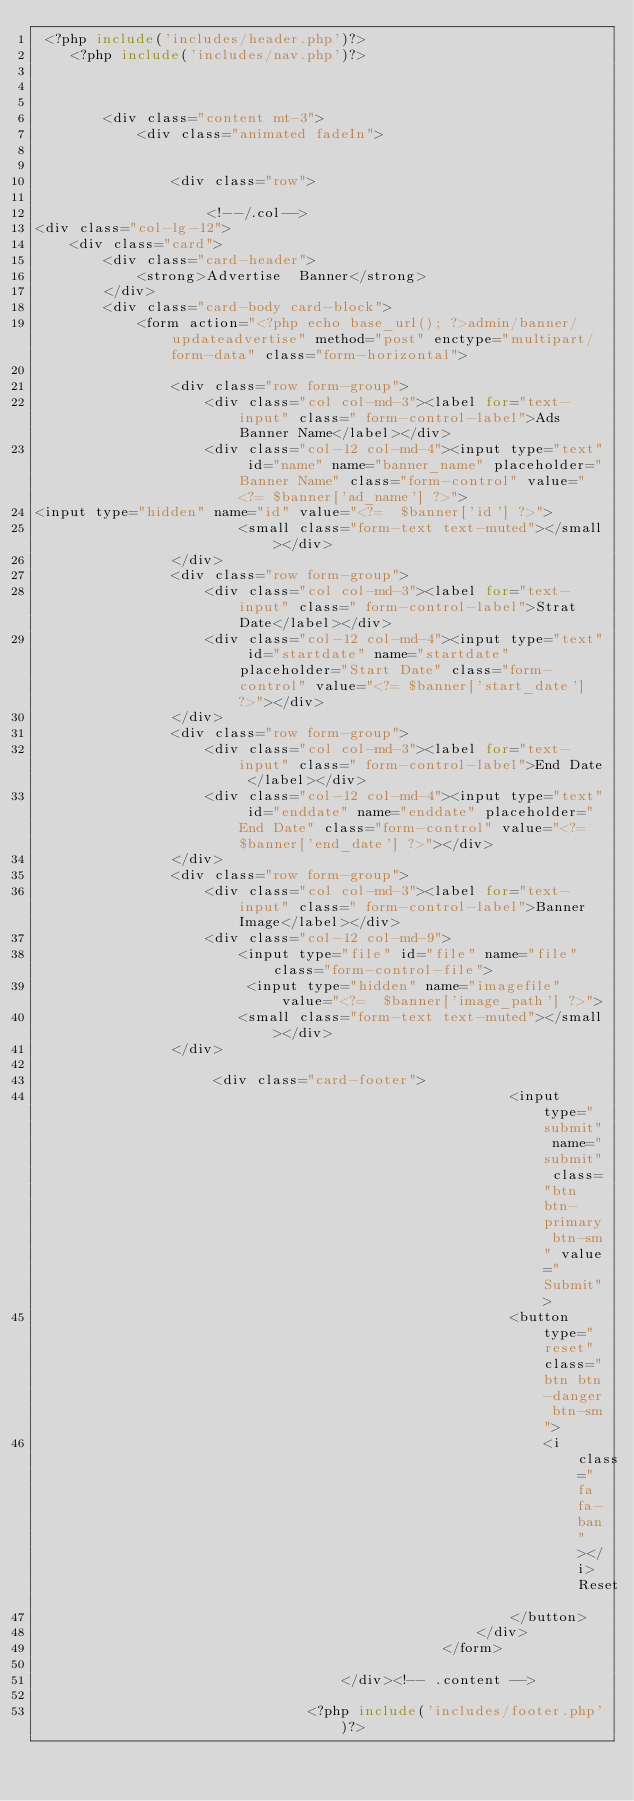Convert code to text. <code><loc_0><loc_0><loc_500><loc_500><_PHP_> <?php include('includes/header.php')?>
    <?php include('includes/nav.php')?>
 


        <div class="content mt-3">
            <div class="animated fadeIn">


                <div class="row">
                    
                    <!--/.col-->
<div class="col-lg-12">
    <div class="card">
        <div class="card-header">
            <strong>Advertise  Banner</strong>
        </div>
        <div class="card-body card-block">
            <form action="<?php echo base_url(); ?>admin/banner/updateadvertise" method="post" enctype="multipart/form-data" class="form-horizontal">
                
                <div class="row form-group">
                    <div class="col col-md-3"><label for="text-input" class=" form-control-label">Ads Banner Name</label></div>
                    <div class="col-12 col-md-4"><input type="text" id="name" name="banner_name" placeholder="Banner Name" class="form-control" value="<?= $banner['ad_name'] ?>">
<input type="hidden" name="id" value="<?=  $banner['id'] ?>">
                        <small class="form-text text-muted"></small></div>
                </div>
                <div class="row form-group">
                    <div class="col col-md-3"><label for="text-input" class=" form-control-label">Strat Date</label></div>
                    <div class="col-12 col-md-4"><input type="text" id="startdate" name="startdate" placeholder="Start Date" class="form-control" value="<?= $banner['start_date'] ?>"></div>
                </div>
                <div class="row form-group">
                    <div class="col col-md-3"><label for="text-input" class=" form-control-label">End Date </label></div>
                    <div class="col-12 col-md-4"><input type="text" id="enddate" name="enddate" placeholder="End Date" class="form-control" value="<?= $banner['end_date'] ?>"></div>
                </div>
                <div class="row form-group">
                    <div class="col col-md-3"><label for="text-input" class=" form-control-label">Banner Image</label></div>
                    <div class="col-12 col-md-9">
                        <input type="file" id="file" name="file" class="form-control-file">
                         <input type="hidden" name="imagefile" value="<?=  $banner['image_path'] ?>">
                        <small class="form-text text-muted"></small></div>
                </div>
               
                     <div class="card-footer">
                                                        <input  type="submit" name="submit" class="btn btn-primary btn-sm" value="Submit">
                                                        <button type="reset" class="btn btn-danger btn-sm">
                                                            <i class="fa fa-ban"></i> Reset
                                                        </button>
                                                    </div>
                                                </form>
                                                               
                                    </div><!-- .content -->
                               
                                <?php include('includes/footer.php')?></code> 